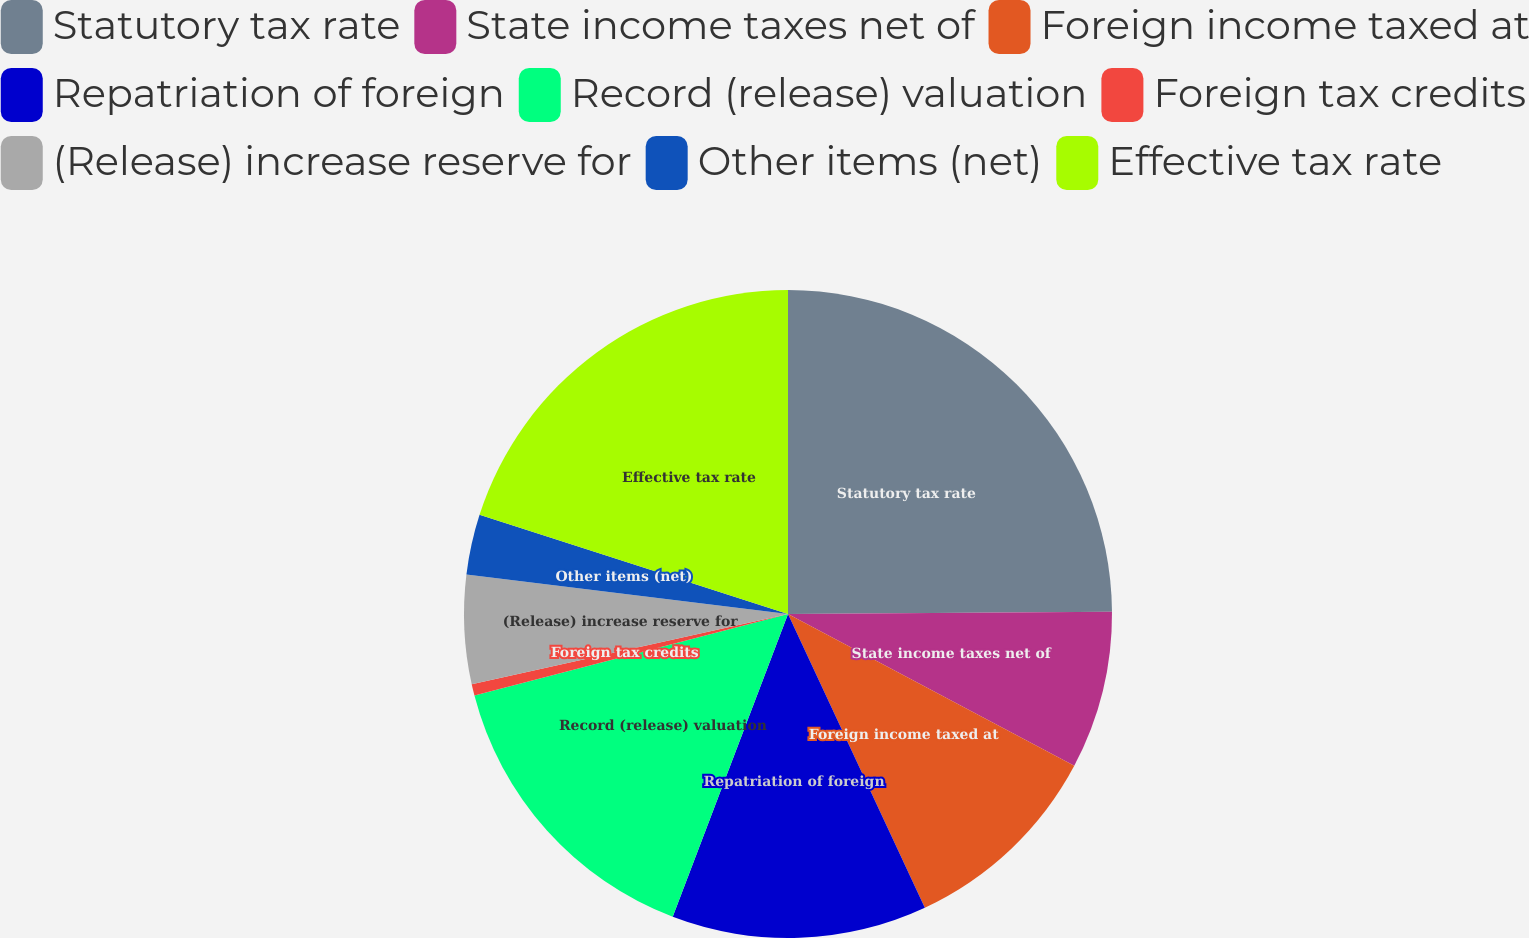<chart> <loc_0><loc_0><loc_500><loc_500><pie_chart><fcel>Statutory tax rate<fcel>State income taxes net of<fcel>Foreign income taxed at<fcel>Repatriation of foreign<fcel>Record (release) valuation<fcel>Foreign tax credits<fcel>(Release) increase reserve for<fcel>Other items (net)<fcel>Effective tax rate<nl><fcel>24.89%<fcel>7.87%<fcel>10.3%<fcel>12.73%<fcel>15.16%<fcel>0.57%<fcel>5.43%<fcel>3.0%<fcel>20.05%<nl></chart> 